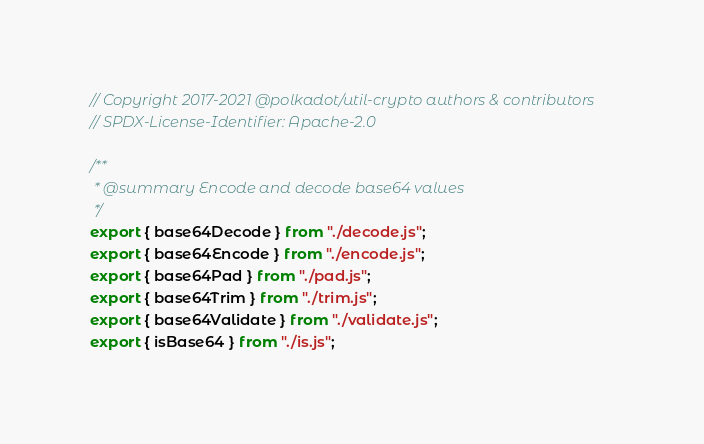Convert code to text. <code><loc_0><loc_0><loc_500><loc_500><_JavaScript_>// Copyright 2017-2021 @polkadot/util-crypto authors & contributors
// SPDX-License-Identifier: Apache-2.0

/**
 * @summary Encode and decode base64 values
 */
export { base64Decode } from "./decode.js";
export { base64Encode } from "./encode.js";
export { base64Pad } from "./pad.js";
export { base64Trim } from "./trim.js";
export { base64Validate } from "./validate.js";
export { isBase64 } from "./is.js";</code> 